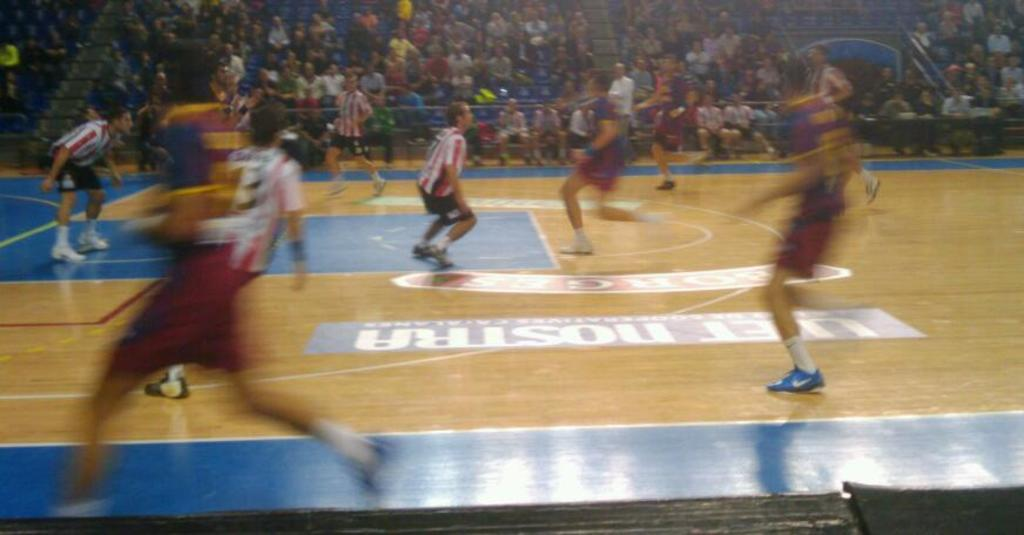What is happening with the group of people in the image? The group of people is on the ground in the image. Can you describe the people in the background of the image? There are people visible in the background of the image. What type of meat is being served on the ship in the image? There is no ship or meat present in the image; it features a group of people on the ground and people in the background. 